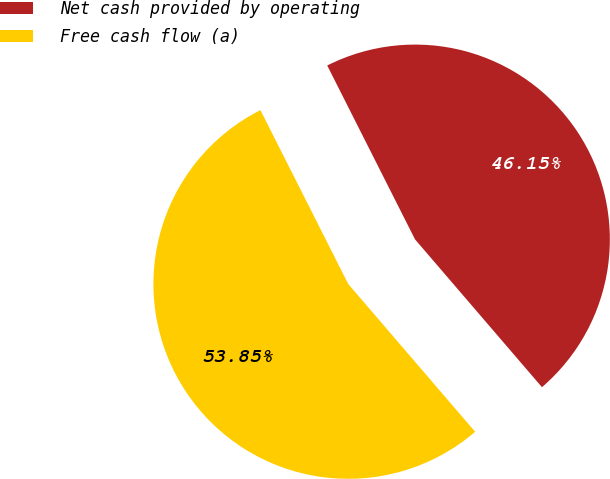Convert chart. <chart><loc_0><loc_0><loc_500><loc_500><pie_chart><fcel>Net cash provided by operating<fcel>Free cash flow (a)<nl><fcel>46.15%<fcel>53.85%<nl></chart> 